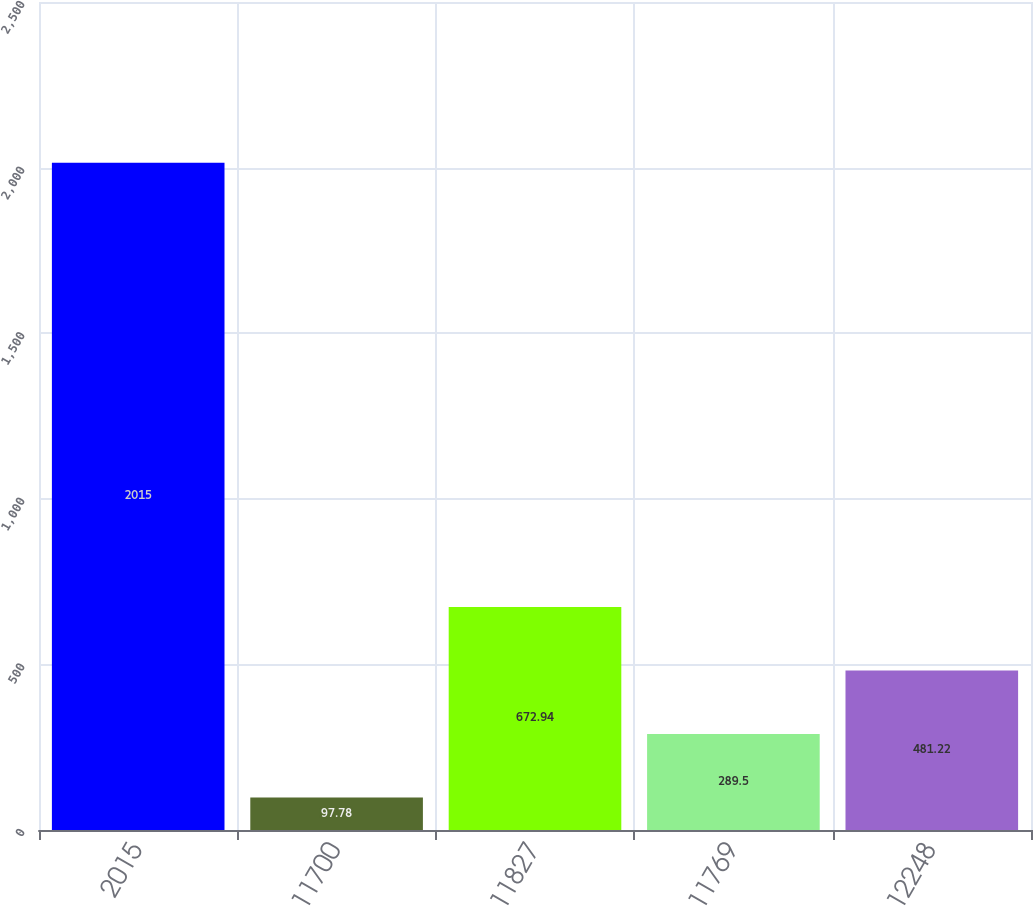<chart> <loc_0><loc_0><loc_500><loc_500><bar_chart><fcel>2015<fcel>11700<fcel>11827<fcel>11769<fcel>12248<nl><fcel>2015<fcel>97.78<fcel>672.94<fcel>289.5<fcel>481.22<nl></chart> 